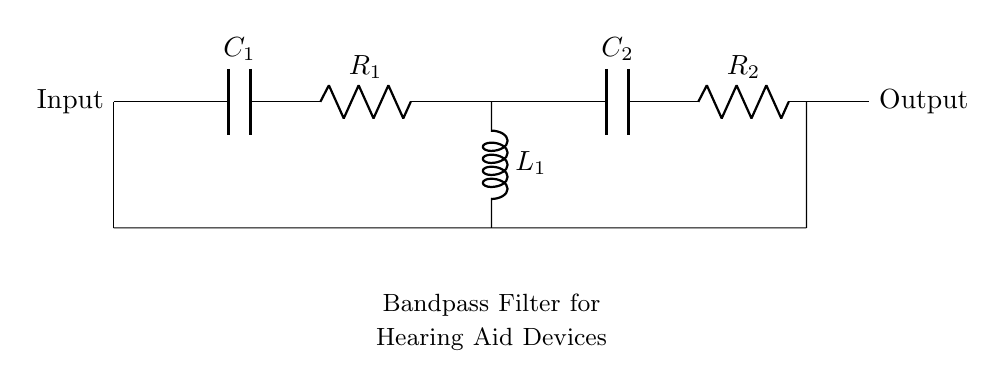What is the type of filter represented in the circuit? The circuit is designed as a bandpass filter, which passes signals within a certain frequency range while attenuating signals outside this range. This can be inferred from the combination of capacitors, resistors, and an inductor used in the diagram.
Answer: Bandpass filter What are the components in this circuit? The components visible in the circuit include two capacitors (C1 and C2), two resistors (R1 and R2), and one inductor (L1). Each component is labeled clearly in the diagram, identifying their respective functions in the circuit.
Answer: Capacitors, resistors, inductor What is the function of the capacitor C1? Capacitor C1 functions as a coupling capacitor, allowing AC signals to pass while blocking DC components, thus ensuring that the filter focuses on specific frequency ranges relevant for hearing. This can be understood by its placement at the input of the circuit.
Answer: Coupling capacitor What is the role of the inductor L1 in this circuit? Inductor L1 contributes to the bandpass filter's characteristics by allowing signals of certain frequencies to pass while blocking others, creating resonance effects in combination with the capacitors. This is crucial for filtering out unwanted frequencies in hearing aid devices.
Answer: Filtering unwanted frequencies How does R1 interact with other components in the circuit? Resistor R1 is in series with capacitor C1 and influences the time constant of the circuit, which determines how quickly the circuit responds to input signals. Its value affects both the cutoff frequency and the overall impedance of the bandpass filter, impacting speech clarity.
Answer: Influences time constant What frequency range does this filter target? While the specific frequency range cannot be determined without values for the components, bandpass filters in hearing aids typically target frequencies around one to four kilohertz. This is aligned with the range where human speech primarily occurs, enhancing clarity.
Answer: One to four kilohertz What is the importance of using a bandpass filter in hearing aids? A bandpass filter is essential in hearing aids as it enhances the clarity of speech by amplifying frequencies essential for communication while reducing background noise. This specificity optimizes listening experiences for users in various environments.
Answer: Enhances speech clarity 